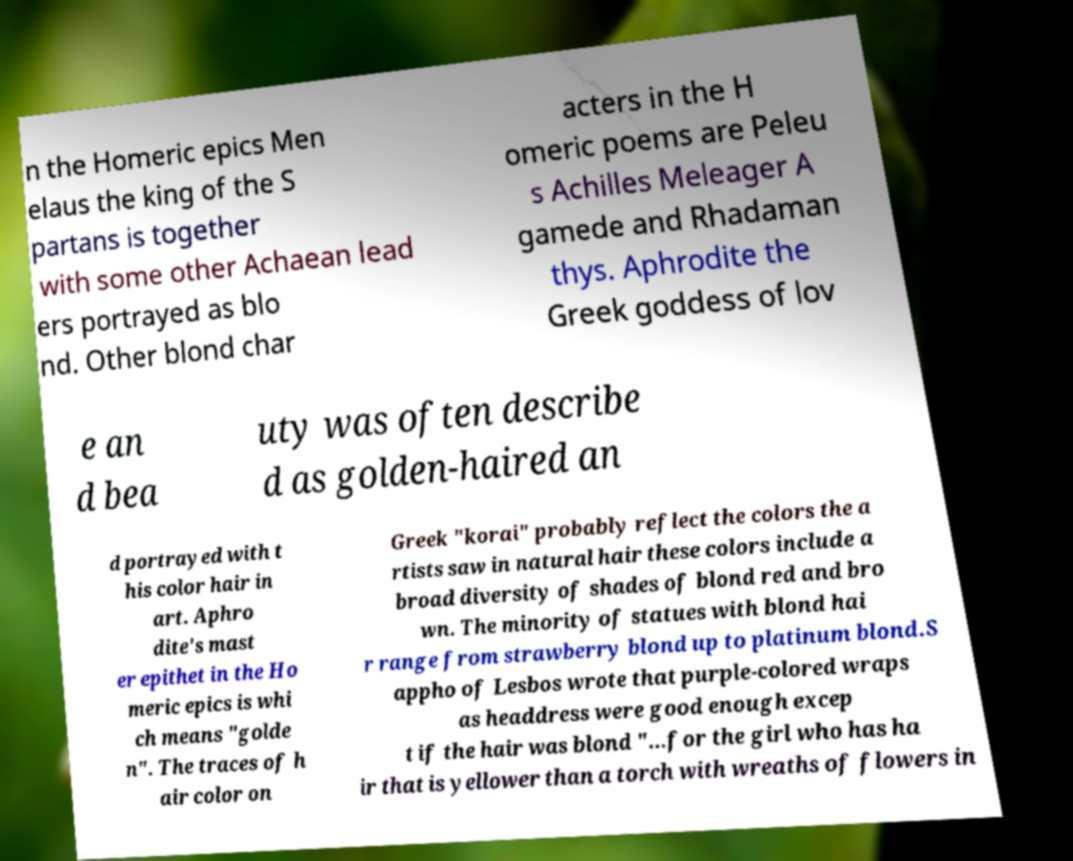Can you accurately transcribe the text from the provided image for me? n the Homeric epics Men elaus the king of the S partans is together with some other Achaean lead ers portrayed as blo nd. Other blond char acters in the H omeric poems are Peleu s Achilles Meleager A gamede and Rhadaman thys. Aphrodite the Greek goddess of lov e an d bea uty was often describe d as golden-haired an d portrayed with t his color hair in art. Aphro dite's mast er epithet in the Ho meric epics is whi ch means "golde n". The traces of h air color on Greek "korai" probably reflect the colors the a rtists saw in natural hair these colors include a broad diversity of shades of blond red and bro wn. The minority of statues with blond hai r range from strawberry blond up to platinum blond.S appho of Lesbos wrote that purple-colored wraps as headdress were good enough excep t if the hair was blond "...for the girl who has ha ir that is yellower than a torch with wreaths of flowers in 